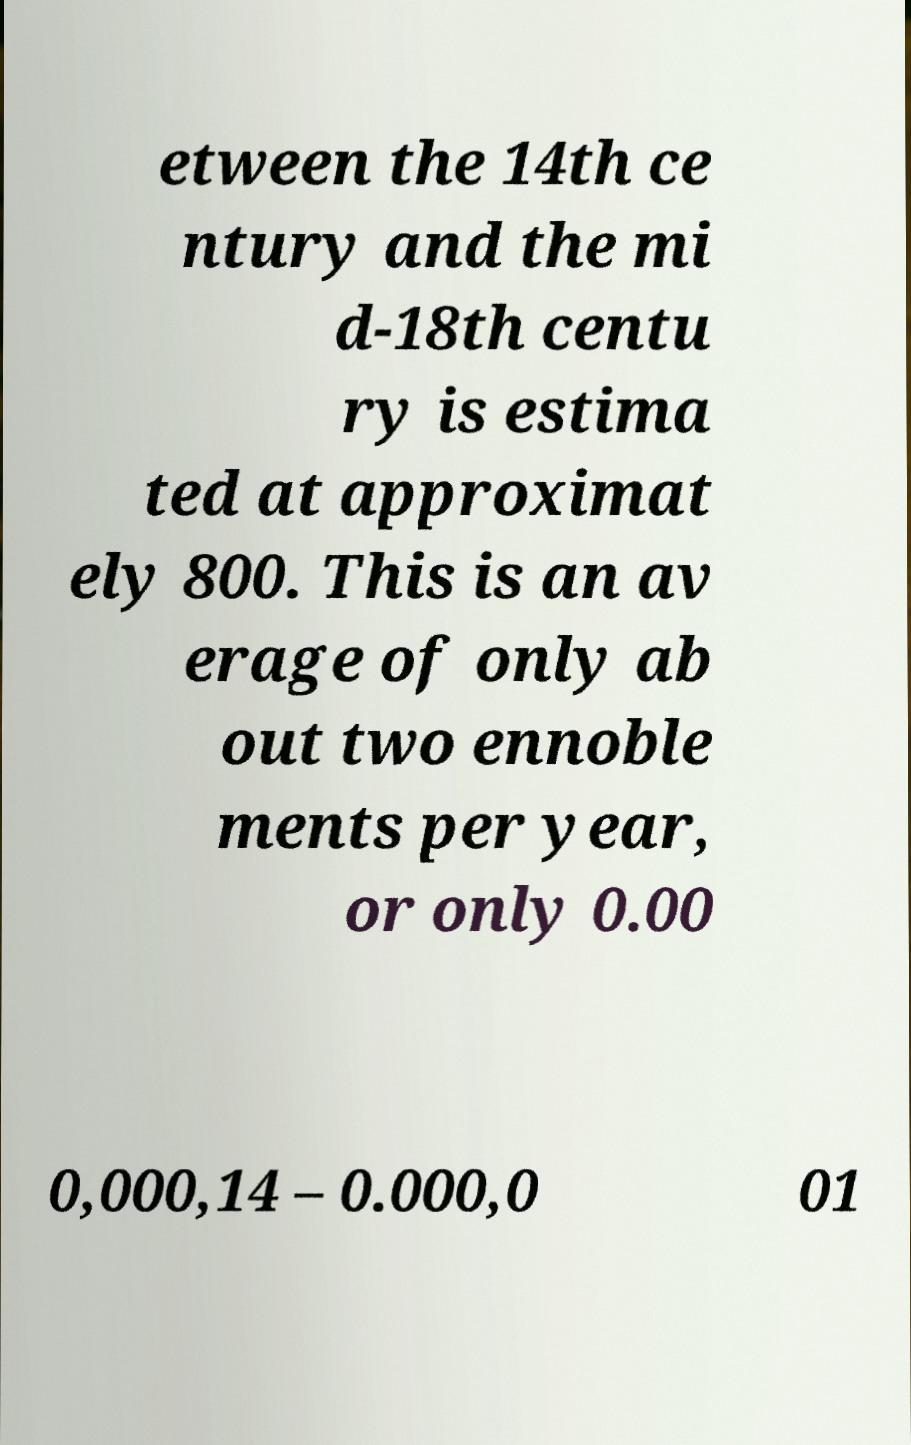There's text embedded in this image that I need extracted. Can you transcribe it verbatim? etween the 14th ce ntury and the mi d-18th centu ry is estima ted at approximat ely 800. This is an av erage of only ab out two ennoble ments per year, or only 0.00 0,000,14 – 0.000,0 01 